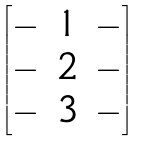Convert formula to latex. <formula><loc_0><loc_0><loc_500><loc_500>\begin{bmatrix} - & { 1 } & - \\ - & { 2 } & - \\ - & { 3 } & - \end{bmatrix}</formula> 